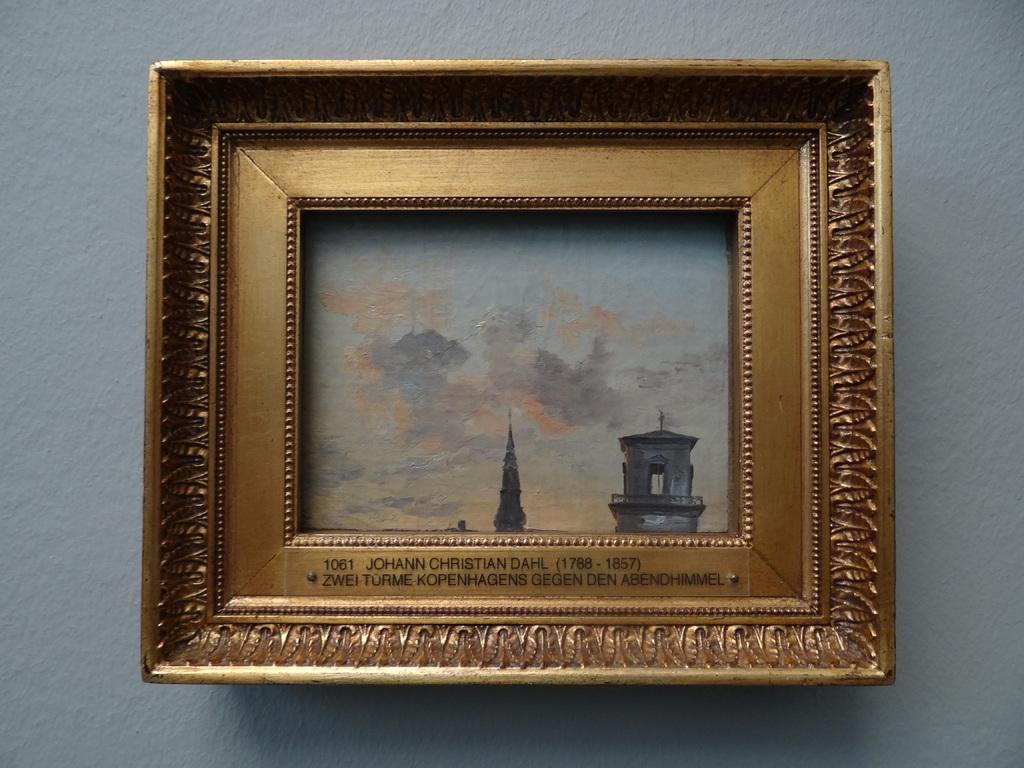<image>
Present a compact description of the photo's key features. A painting hanging on the wall by Johann Christian Dahl 